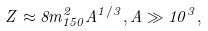Convert formula to latex. <formula><loc_0><loc_0><loc_500><loc_500>Z \approx 8 m _ { 1 5 0 } ^ { 2 } A ^ { 1 / 3 } , A \gg 1 0 ^ { 3 } ,</formula> 